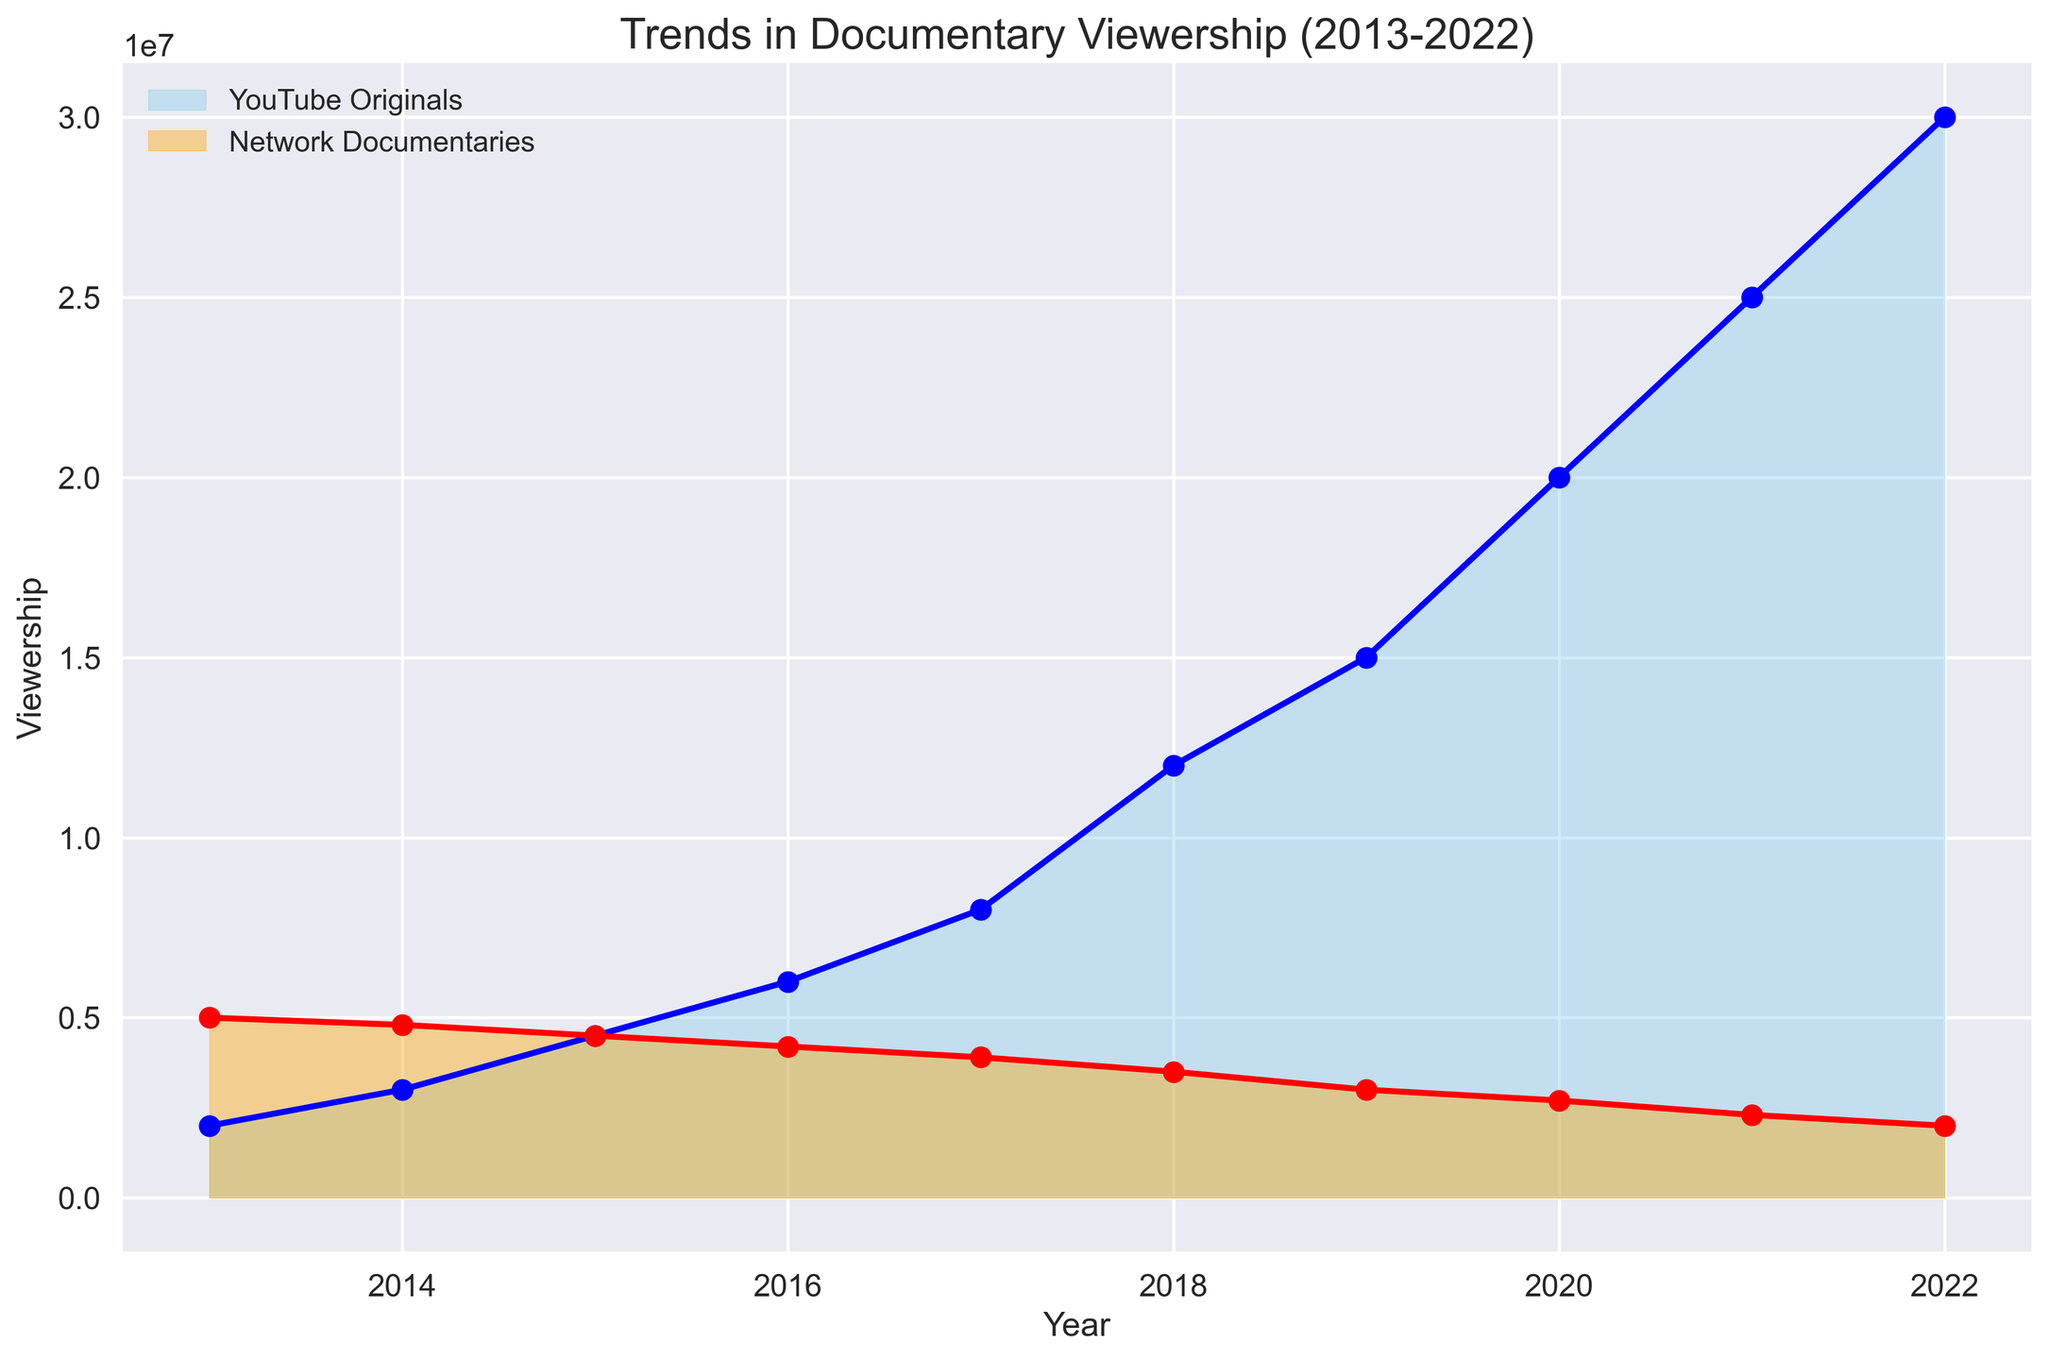What trend do you observe in YouTube Originals viewership from 2013 to 2022? From 2013 to 2022, the viewership of YouTube Originals continuously increased every year, starting at 2,000,000 in 2013 and rising to 30,000,000 in 2022.
Answer: Steady increase How did the viewership of Network Documentaries change from 2013 to 2022? The viewership of Network Documentaries showed a steady decline from 5,000,000 in 2013 to 2,000,000 in 2022.
Answer: Steady decline Which year did YouTube Originals viewership surpass Network Documentaries viewership? In 2015, YouTube Originals viewership (4,500,000) surpassed Network Documentaries viewership (4,500,000).
Answer: 2015 What is the difference in viewership between YouTube Originals and Network Documentaries in 2022? In 2022, the viewership of YouTube Originals was 30,000,000 and for Network Documentaries it was 2,000,000. The difference is 30,000,000 - 2,000,000, which equals 28,000,000.
Answer: 28,000,000 In which year did YouTube Originals see the largest annual increase in viewership? Between 2019 and 2020, YouTube Originals viewership increased from 15,000,000 to 20,000,000, which is an increase of 5,000,000—the largest annual increase observed.
Answer: 2020 Compare the growth rates of YouTube Originals and Network Documentaries from 2013 to 2022. YouTube Originals grew from 2,000,000 to 30,000,000, while Network Documentaries decreased from 5,000,000 to 2,000,000. The growth rate for YouTube Originals is significantly higher compared to the decline in Network Documentaries over the same period.
Answer: YouTube Originals grew rapidly; Network Documentaries declined How does the area under the curve for YouTube Originals compare with Network Documentaries? The area under the curve for YouTube Originals is much larger due to the significant increase in viewership over time, while the area for Network Documentaries diminishes due to the decline in viewership.
Answer: Much larger for YouTube Originals What is the average viewership of YouTube Originals from 2013 to 2022? To find the average viewership, sum the yearly viewership figures of YouTube Originals (from 2013 to 2022) and divide by the number of years. The total is 142,000,000, so the average is 142,000,000/10 = 14,200,000.
Answer: 14,200,000 